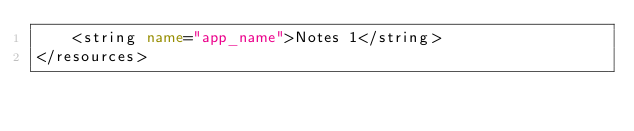Convert code to text. <code><loc_0><loc_0><loc_500><loc_500><_XML_>    <string name="app_name">Notes 1</string>
</resources></code> 